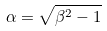<formula> <loc_0><loc_0><loc_500><loc_500>\alpha = \sqrt { \beta ^ { 2 } - 1 }</formula> 